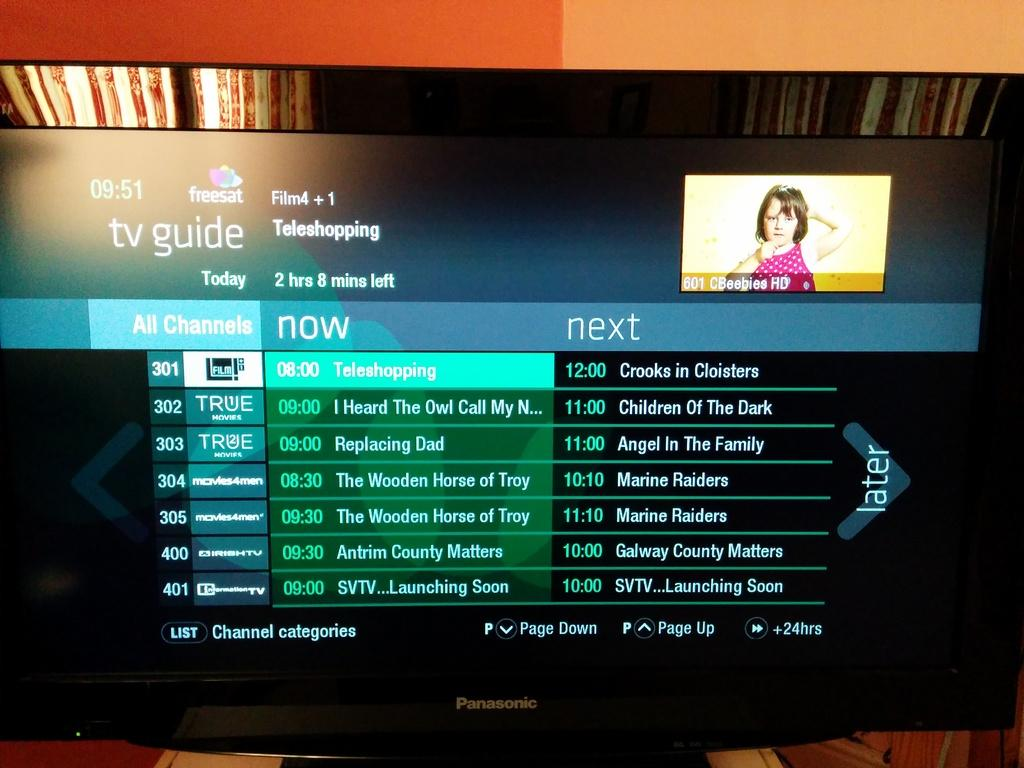<image>
Share a concise interpretation of the image provided. flat screen tv with a screen for the tv guide 